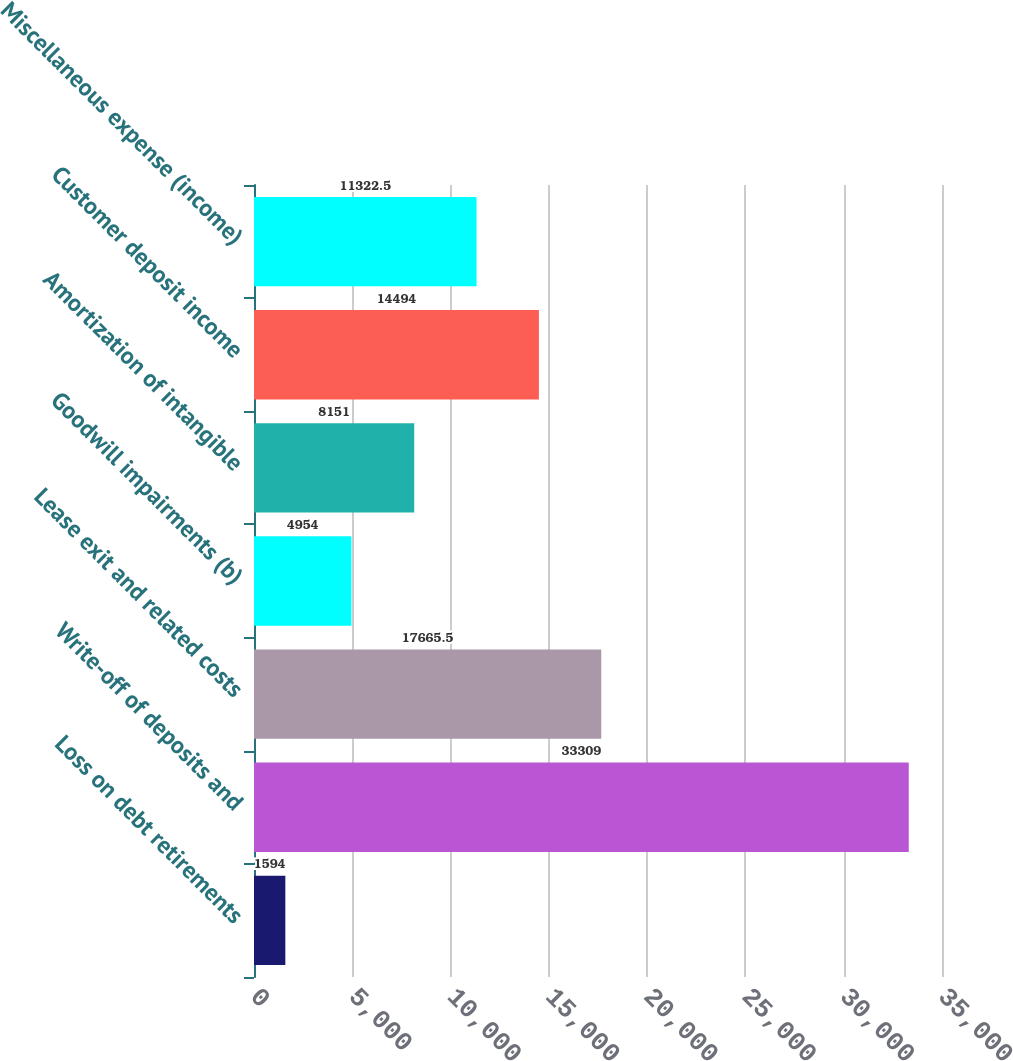<chart> <loc_0><loc_0><loc_500><loc_500><bar_chart><fcel>Loss on debt retirements<fcel>Write-off of deposits and<fcel>Lease exit and related costs<fcel>Goodwill impairments (b)<fcel>Amortization of intangible<fcel>Customer deposit income<fcel>Miscellaneous expense (income)<nl><fcel>1594<fcel>33309<fcel>17665.5<fcel>4954<fcel>8151<fcel>14494<fcel>11322.5<nl></chart> 